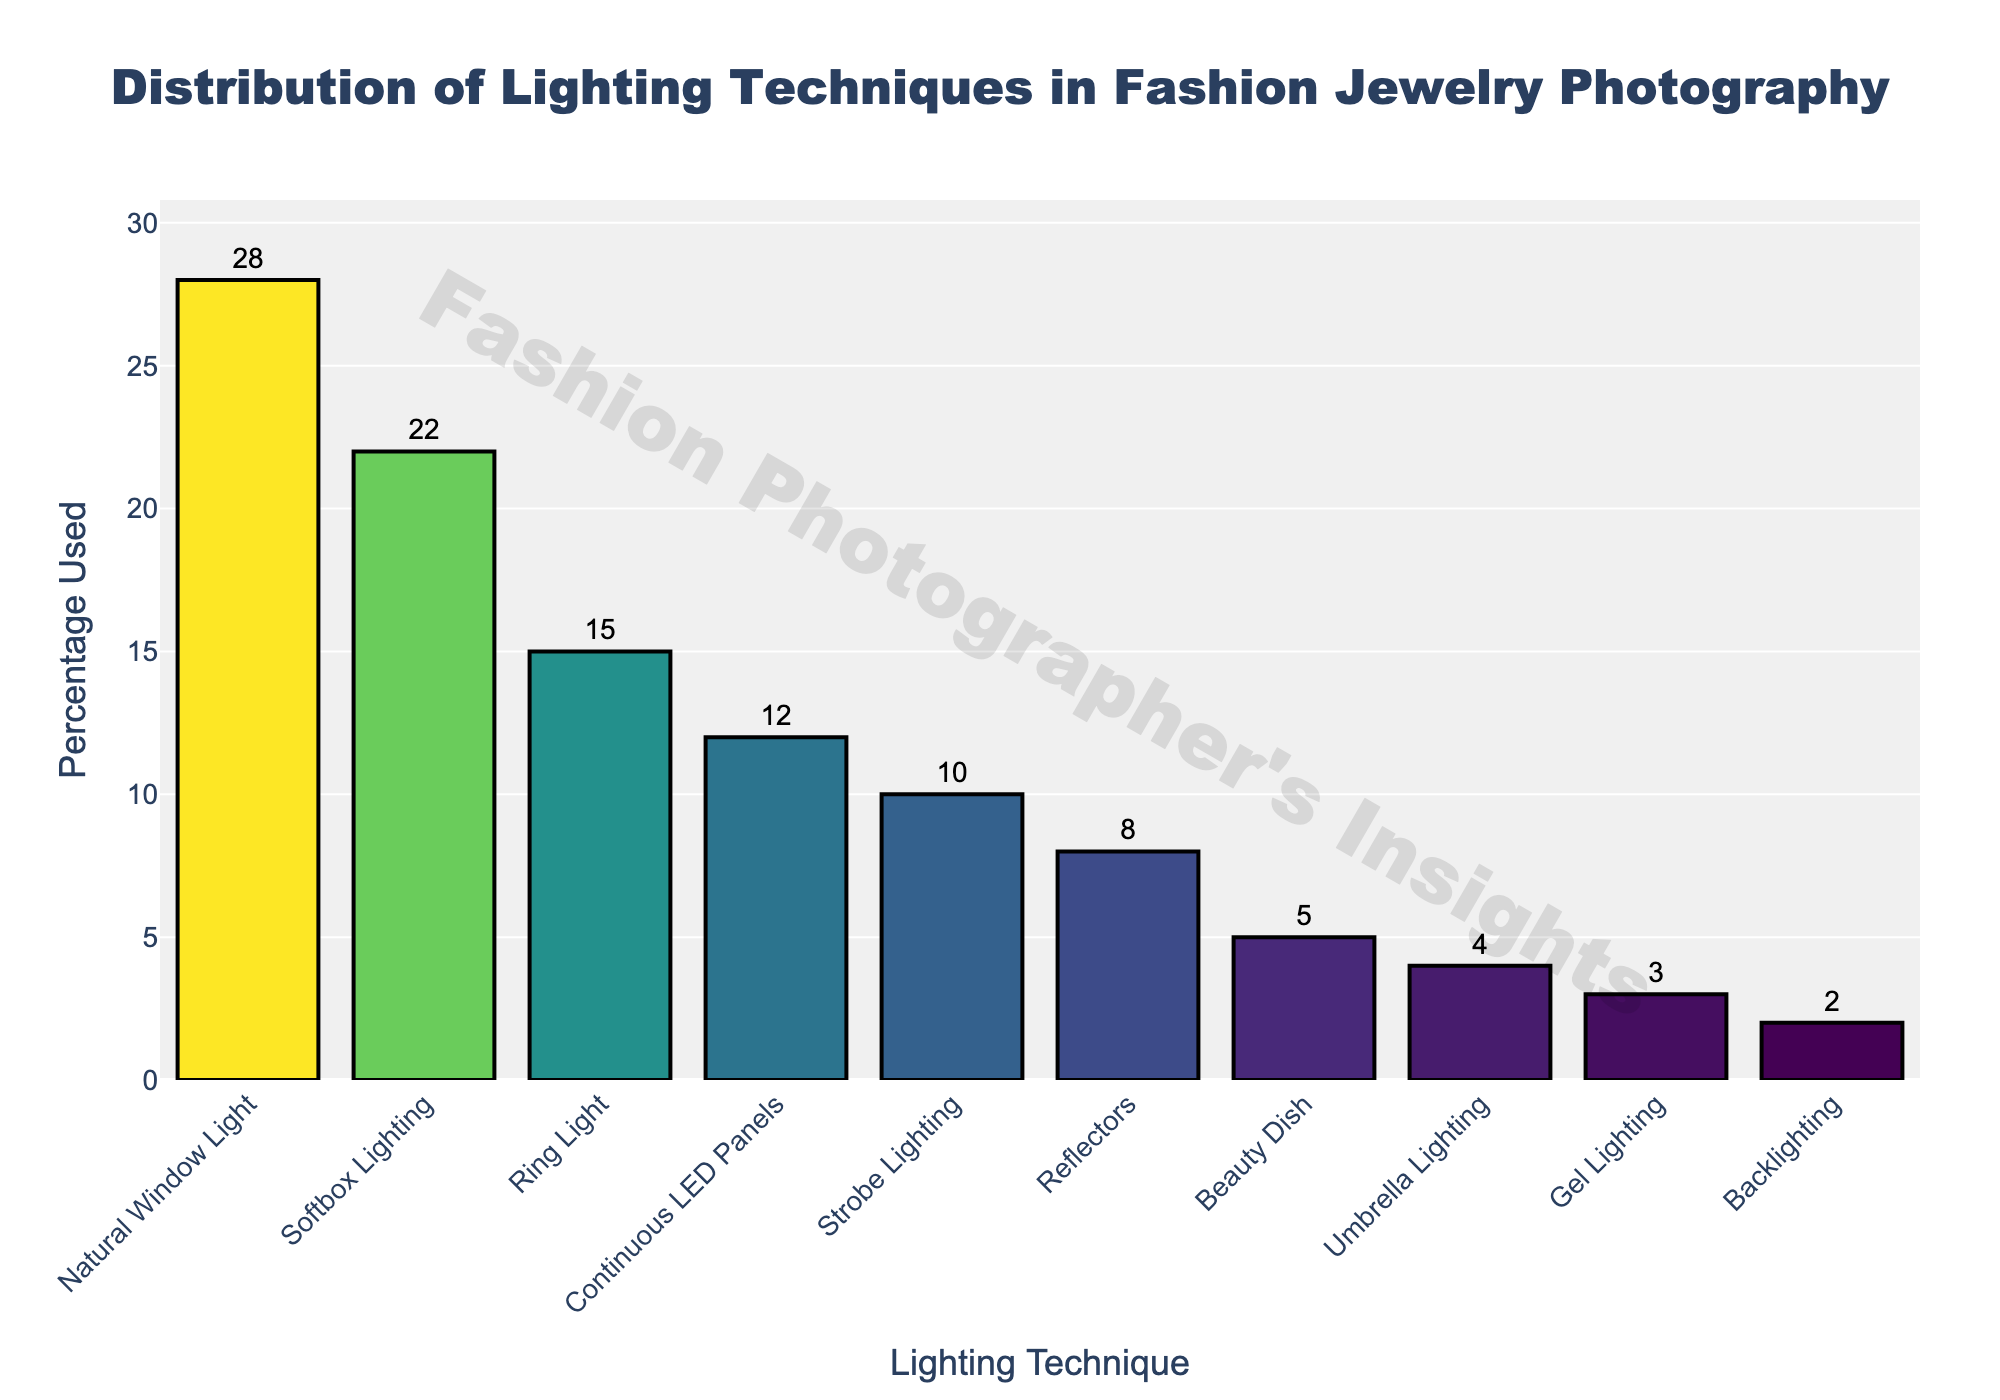what is the most popular lighting technique used in fashion jewelry photography? The bar chart shows that "Natural Window Light" has the highest bar and percentage value of 28%. Therefore, it is the most popular lighting technique.
Answer: Natural Window Light which lighting technique is used the least in fashion jewelry photography? The bar chart shows that "Backlighting" has the smallest bar and percentage value of 2%. Therefore, it is the least used lighting technique.
Answer: Backlighting what's the combined percentage used of Softbox Lighting, Ring Light, and Continuous LED Panels? To calculate the combined percentage, add the individual percentages: 22% (Softbox Lighting) + 15% (Ring Light) + 12% (Continuous LED Panels) = 49%.
Answer: 49% how much more popular is Natural Window Light compared to Strobe Lighting? Subtract the percentage of Strobe Lighting from the percentage of Natural Window Light: 28% (Natural Window Light) - 10% (Strobe Lighting) = 18%.
Answer: 18% does umbrella lighting or beauty dish have a higher usage percentage? Comparing the bar heights, "Beauty Dish" has a percentage of 5%, while "Umbrella Lighting" has 4%. Hence, "Beauty Dish" is used slightly more than "Umbrella Lighting".
Answer: Beauty Dish what percent of techniques are used by less than 10% each? By checking the bars, techniques with less than 10% are: Backlighting (2%), Gel Lighting (3%), Umbrella Lighting (4%), Beauty Dish (5%), Reflectors (8%), and Strobe Lighting (10%). Summing their usage: 2% + 3% + 4% + 5% + 8% + 10% = 32%.
Answer: 32% how does the usage of Ring Light compare to that of Reflectors? The percentage for Ring Light is 15%, and for Reflectors, it is 8%. Ring Light is more popular. The difference is 15% - 8% = 7%.
Answer: 7% which lighting technique falls exactly in the middle of the distribution when ordered by percentage used? When ordered by percentage used, the middle value (5th in a list of 10) is Reflectors with 8%.
Answer: Reflectors how much more popular are Continuous LED Panels compared to Beauty Dish and Umbrella Lighting combined? The usage of Continuous LED Panels is 12%. The combined use of Beauty Dish (5%) and Umbrella Lighting (4%) is 5% + 4% = 9%. 12% - 9% = 3%.
Answer: 3% is there any technique with exactly half the usage of Natural Window Light? Natural Window Light is used 28% of the time. Half of 28% is 14%. None of the techniques have exactly 14%.
Answer: No 